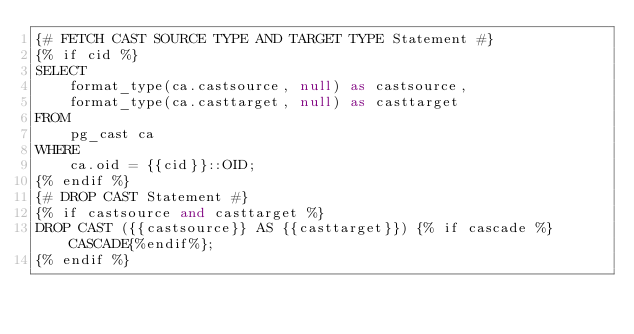<code> <loc_0><loc_0><loc_500><loc_500><_SQL_>{# FETCH CAST SOURCE TYPE AND TARGET TYPE Statement #}
{% if cid %}
SELECT
    format_type(ca.castsource, null) as castsource,
    format_type(ca.casttarget, null) as casttarget
FROM
    pg_cast ca
WHERE
    ca.oid = {{cid}}::OID;
{% endif %}
{# DROP CAST Statement #}
{% if castsource and casttarget %}
DROP CAST ({{castsource}} AS {{casttarget}}) {% if cascade %}CASCADE{%endif%};
{% endif %}</code> 